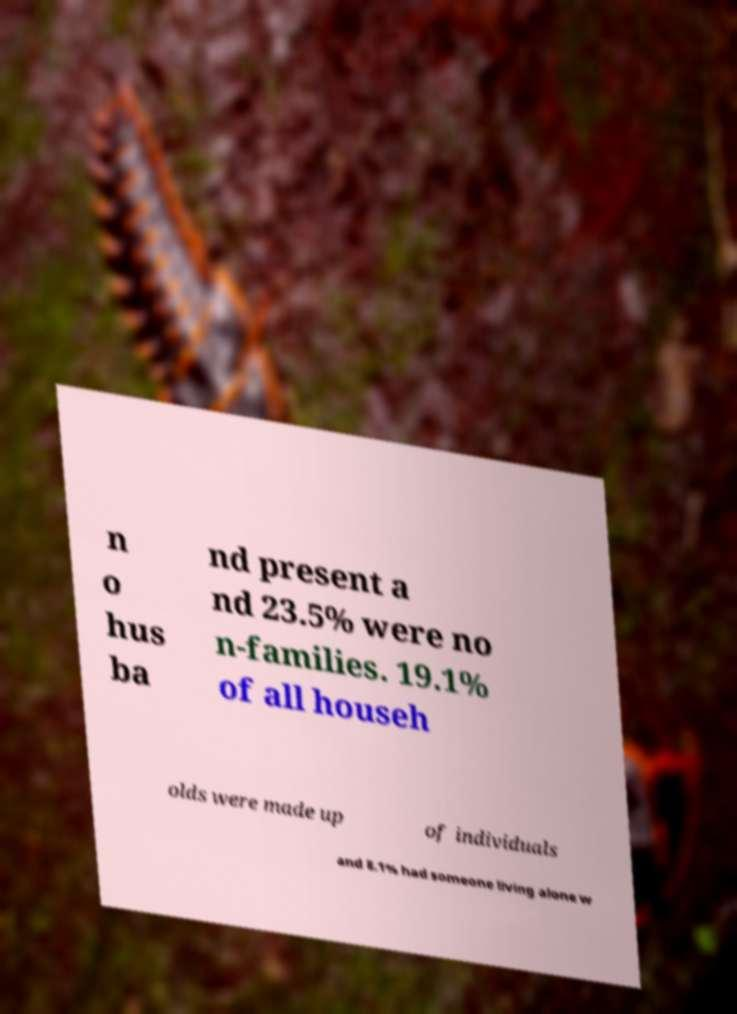Could you assist in decoding the text presented in this image and type it out clearly? n o hus ba nd present a nd 23.5% were no n-families. 19.1% of all househ olds were made up of individuals and 8.1% had someone living alone w 